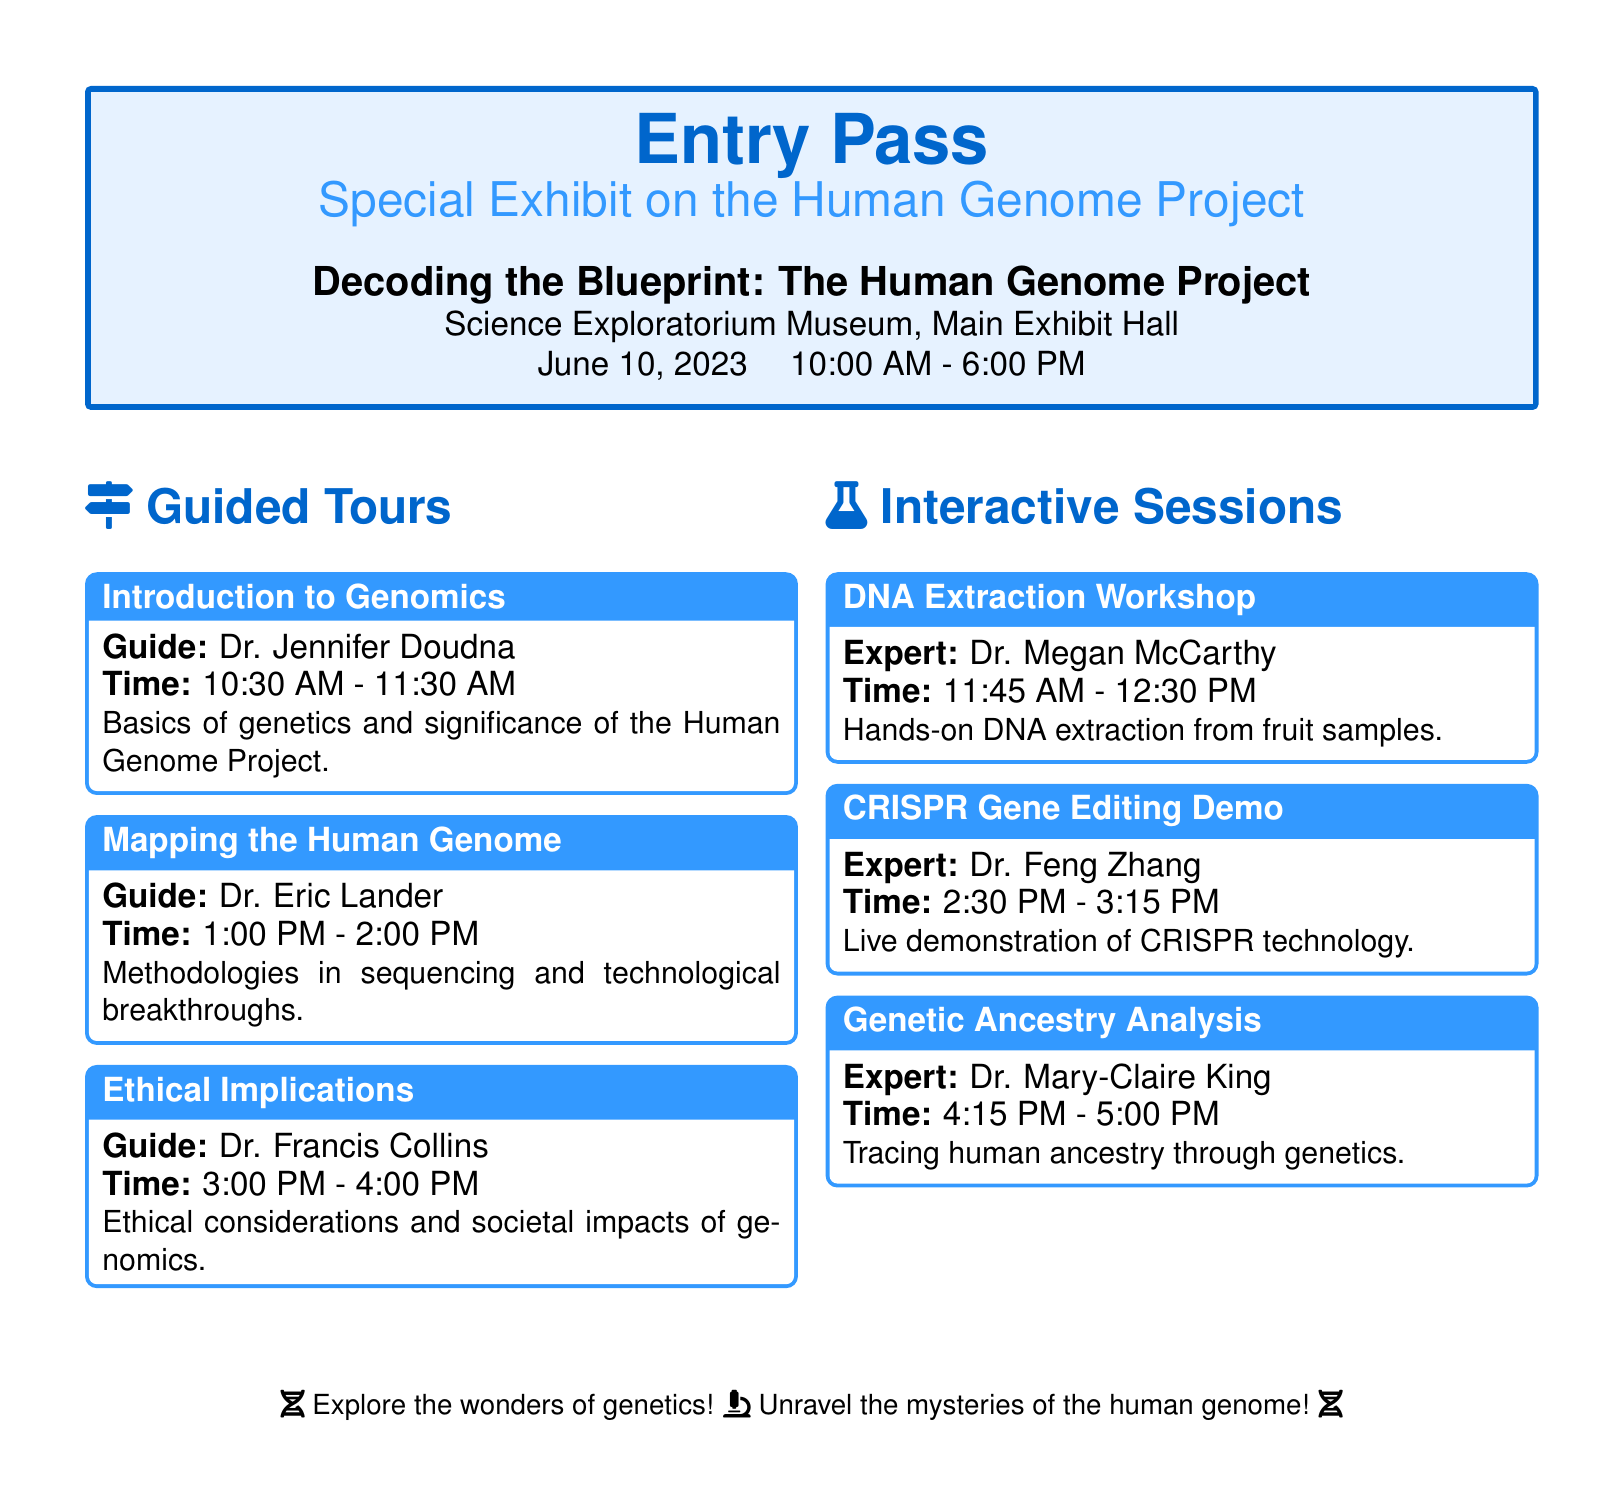What is the title of the exhibit? The title of the exhibit is “Decoding the Blueprint: The Human Genome Project.”
Answer: Decoding the Blueprint: The Human Genome Project Who is the guide for the “Introduction to Genomics” tour? The guide for the “Introduction to Genomics” tour is Dr. Jennifer Doudna.
Answer: Dr. Jennifer Doudna What time does the DNA Extraction Workshop start? The DNA Extraction Workshop starts at 11:45 AM.
Answer: 11:45 AM How many interactive sessions are listed in the document? There are three interactive sessions listed in the document.
Answer: Three What is the focus of the guided tour led by Dr. Francis Collins? The focus of the guided tour led by Dr. Francis Collins is on ethical considerations and societal impacts of genomics.
Answer: Ethical Implications At what time does the CRISPR Gene Editing Demo take place? The CRISPR Gene Editing Demo takes place at 2:30 PM.
Answer: 2:30 PM Which expert leads the Genetic Ancestry Analysis session? The expert leading the Genetic Ancestry Analysis session is Dr. Mary-Claire King.
Answer: Dr. Mary-Claire King What date is the special exhibit scheduled? The special exhibit is scheduled for June 10, 2023.
Answer: June 10, 2023 